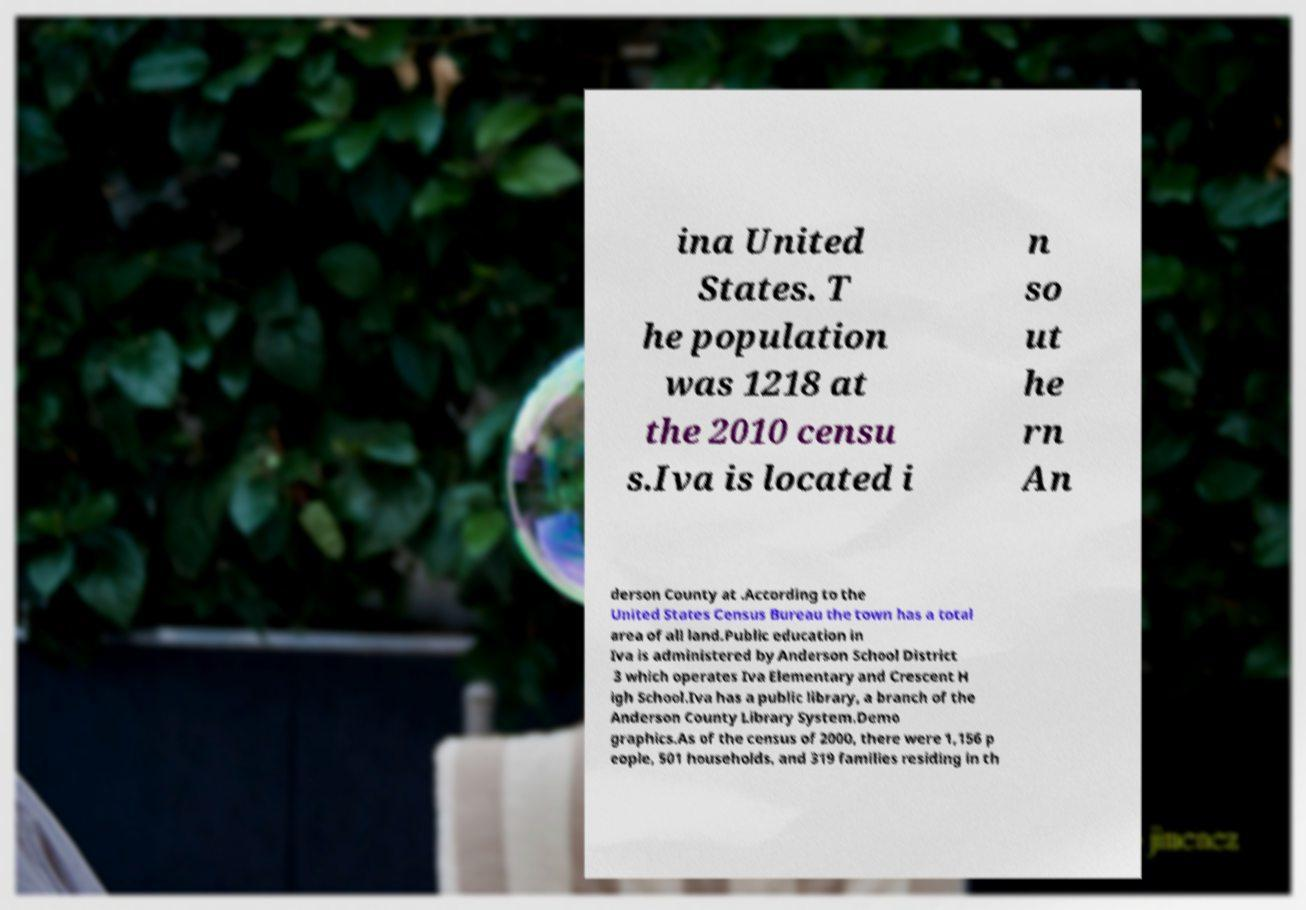Could you extract and type out the text from this image? ina United States. T he population was 1218 at the 2010 censu s.Iva is located i n so ut he rn An derson County at .According to the United States Census Bureau the town has a total area of all land.Public education in Iva is administered by Anderson School District 3 which operates Iva Elementary and Crescent H igh School.Iva has a public library, a branch of the Anderson County Library System.Demo graphics.As of the census of 2000, there were 1,156 p eople, 501 households, and 319 families residing in th 